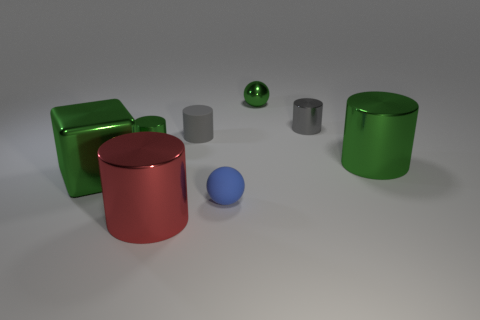How many red things are either tiny matte cylinders or small rubber spheres?
Offer a very short reply. 0. How many objects are blue matte cylinders or big shiny cylinders left of the blue matte thing?
Your answer should be very brief. 1. What is the big object that is to the right of the small green ball made of?
Ensure brevity in your answer.  Metal. There is a green metal object that is the same size as the green sphere; what is its shape?
Make the answer very short. Cylinder. Is there a tiny blue object that has the same shape as the gray shiny object?
Your answer should be compact. No. Is the material of the big green cylinder the same as the tiny ball in front of the big metallic block?
Offer a terse response. No. There is a big cylinder that is on the right side of the thing that is in front of the small blue matte ball; what is it made of?
Your answer should be very brief. Metal. Is the number of tiny cylinders in front of the matte sphere greater than the number of big gray metal blocks?
Keep it short and to the point. No. Are any small gray rubber cylinders visible?
Your answer should be very brief. Yes. The large metallic thing to the right of the gray matte cylinder is what color?
Give a very brief answer. Green. 